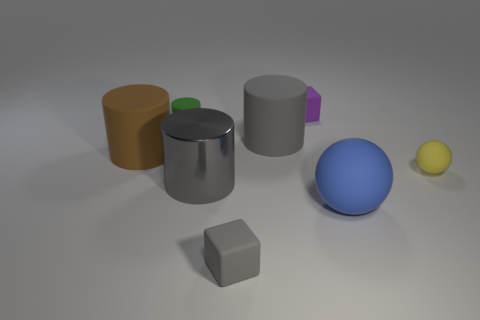What shapes are depicted in the image? The image features a variety of geometric shapes including cylinders, cubes, and spheres. There's a tall cylinder, a shorter one, two cubes of different sizes, and two spheres also varying in size. 